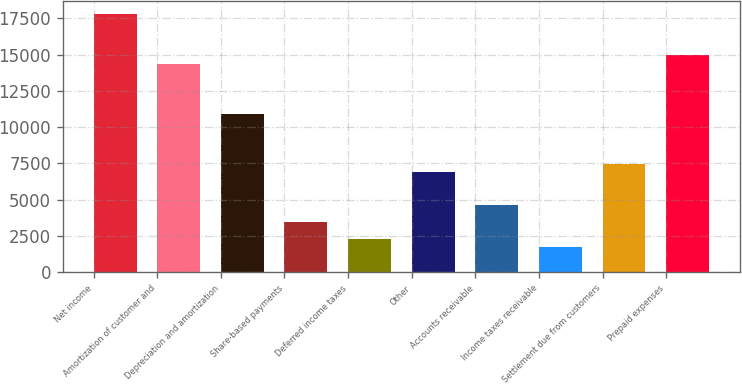Convert chart to OTSL. <chart><loc_0><loc_0><loc_500><loc_500><bar_chart><fcel>Net income<fcel>Amortization of customer and<fcel>Depreciation and amortization<fcel>Share-based payments<fcel>Deferred income taxes<fcel>Other<fcel>Accounts receivable<fcel>Income taxes receivable<fcel>Settlement due from customers<fcel>Prepaid expenses<nl><fcel>17813.6<fcel>14366<fcel>10918.4<fcel>3448.6<fcel>2299.4<fcel>6896.2<fcel>4597.8<fcel>1724.8<fcel>7470.8<fcel>14940.6<nl></chart> 